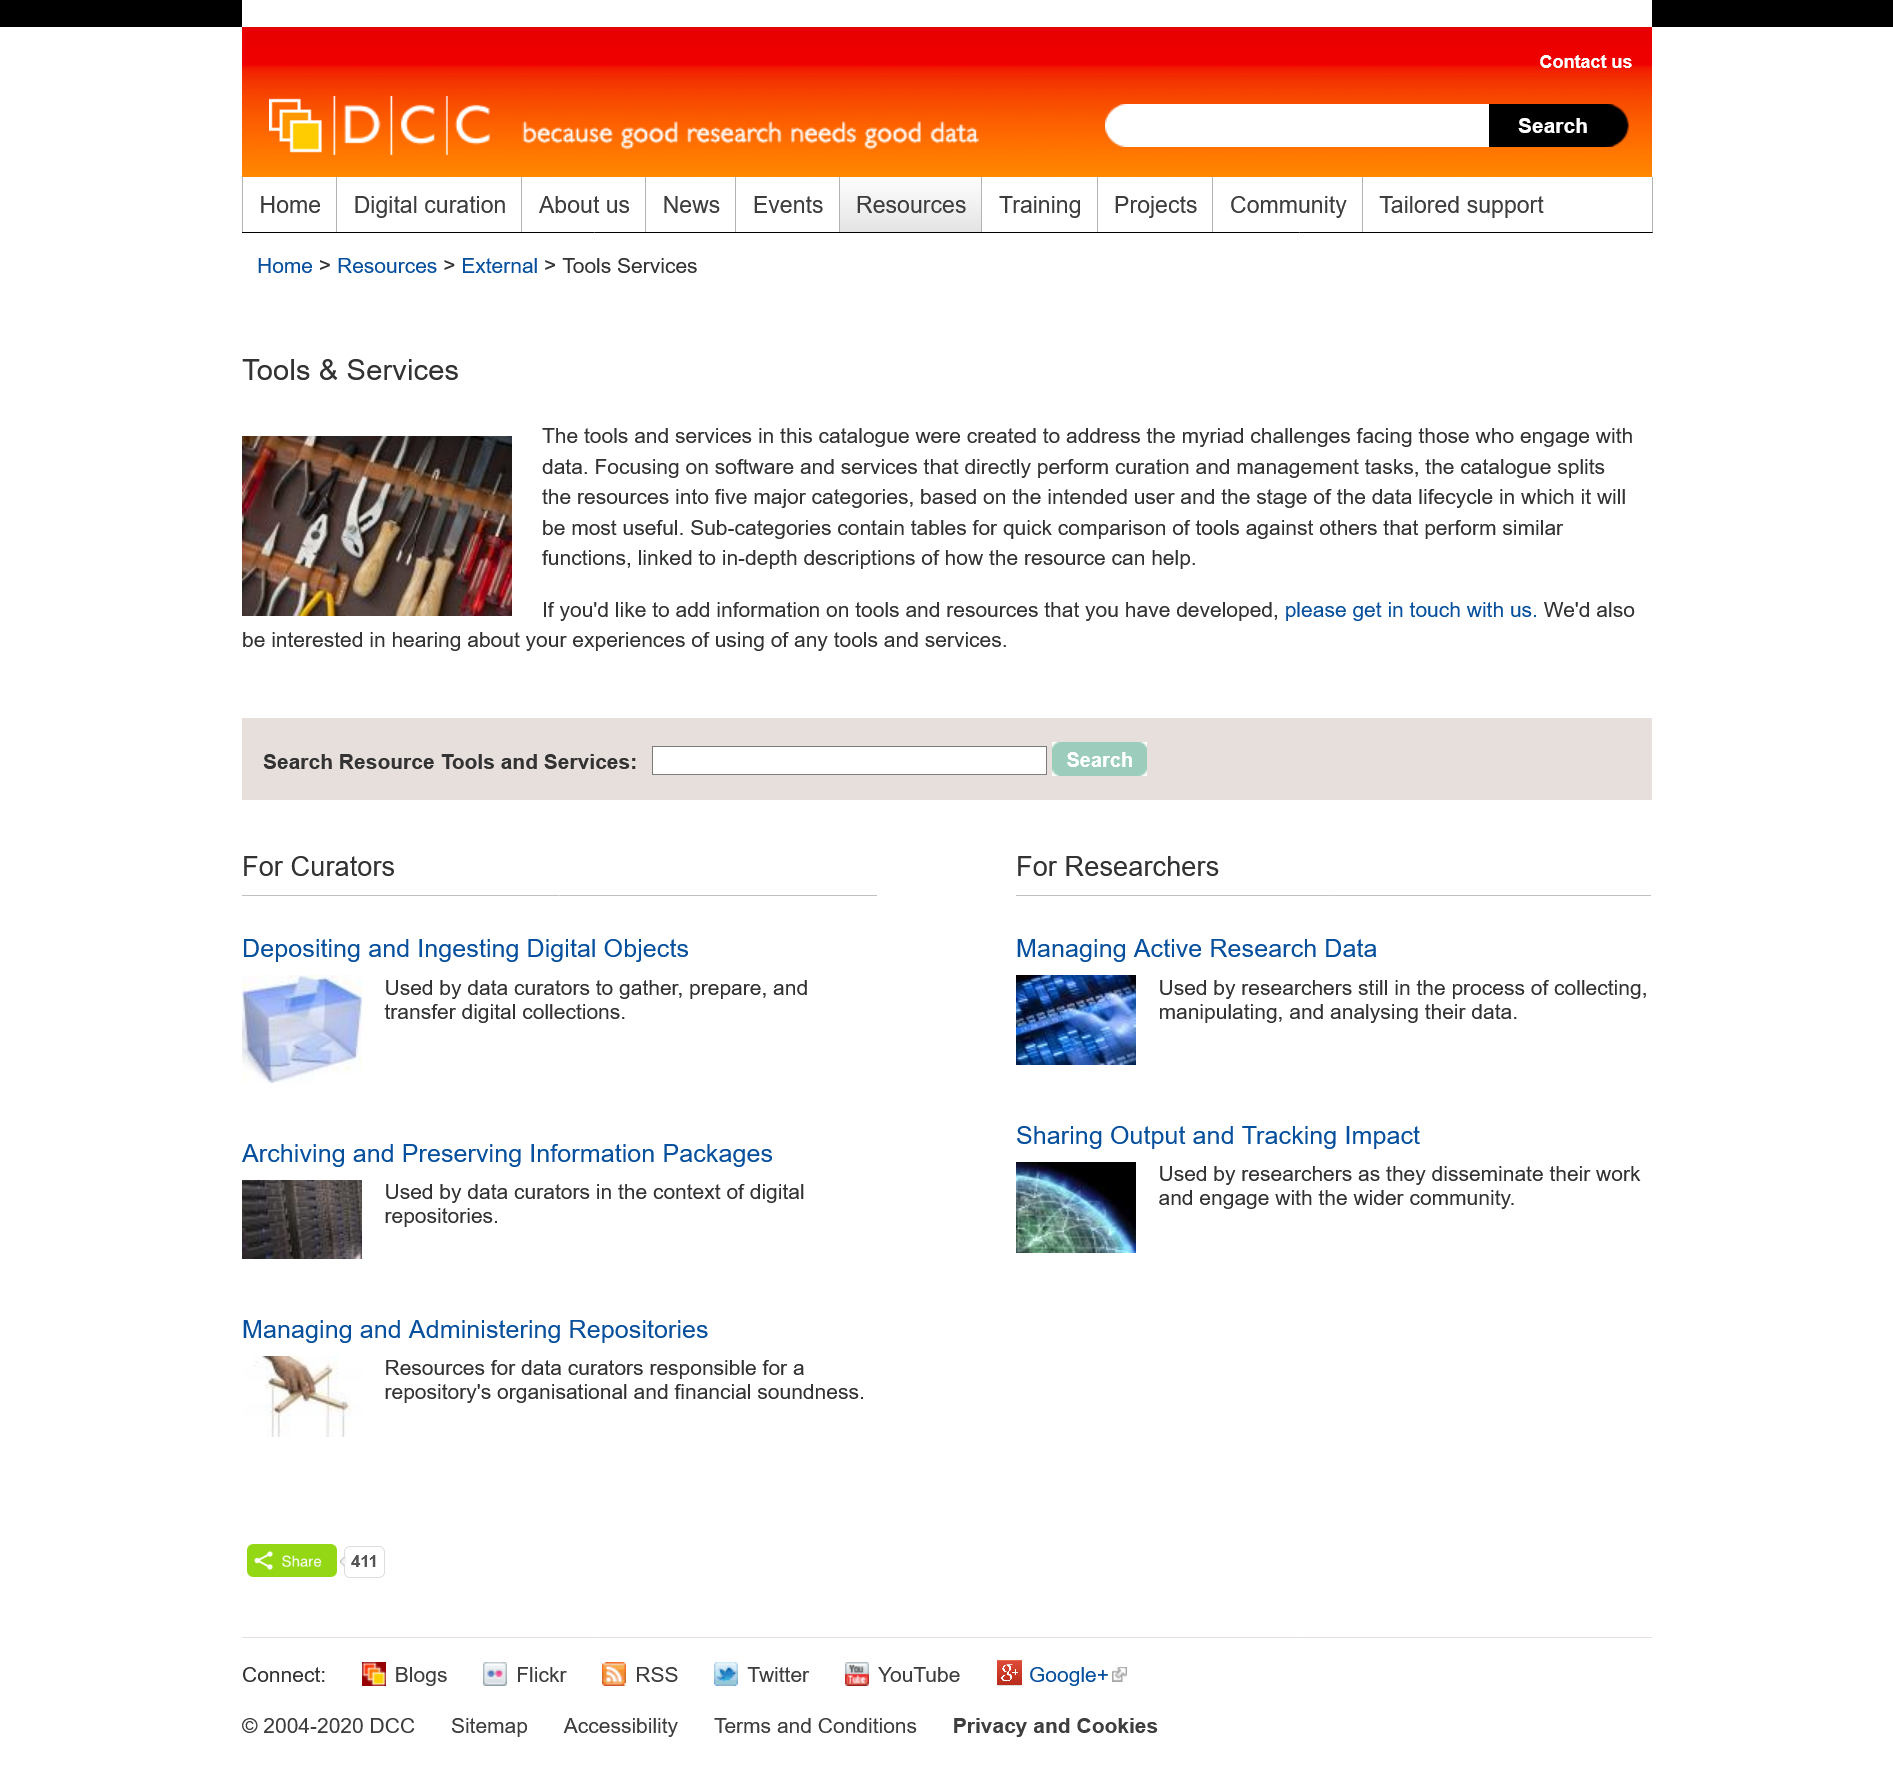List a handful of essential elements in this visual. The tools in the catalogue have been created to address the numerous challenges faced by those who engage with data. We welcome contributions from developers who have developed their own tools and would like to share information about them. Please contact us for more information on how to do so. The left picture depicts an abundance of hand tools, including screws and pliers, which are prominently displayed in the scene. 